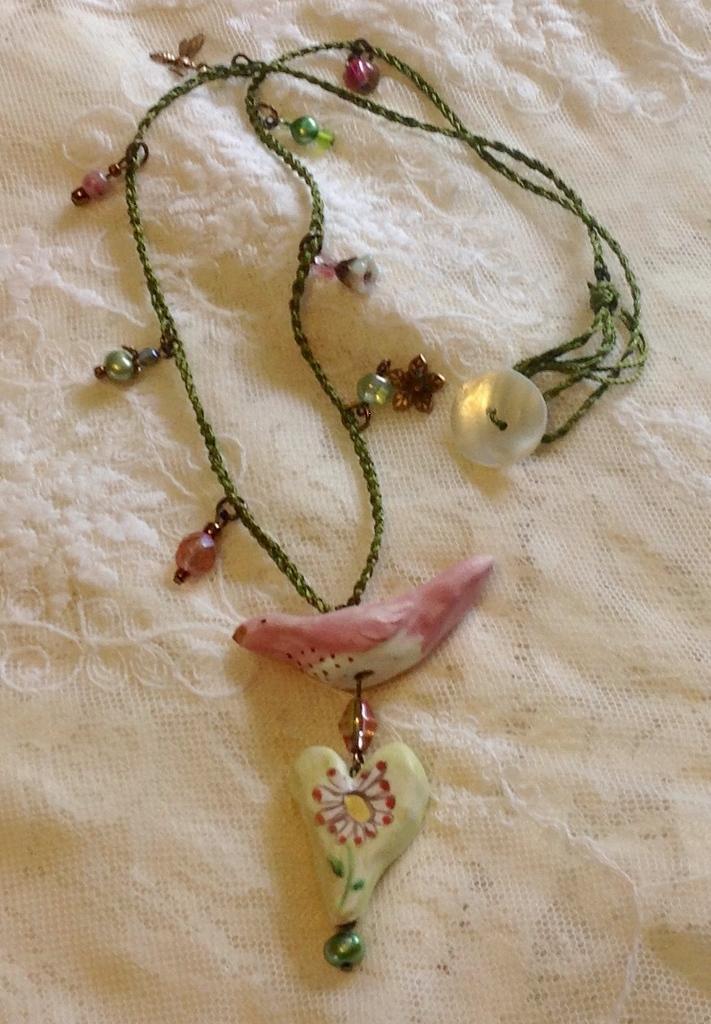Could you give a brief overview of what you see in this image? In the center of the image, we can see a chain, which contains a pendant. At the bottom, there is a cloth. 